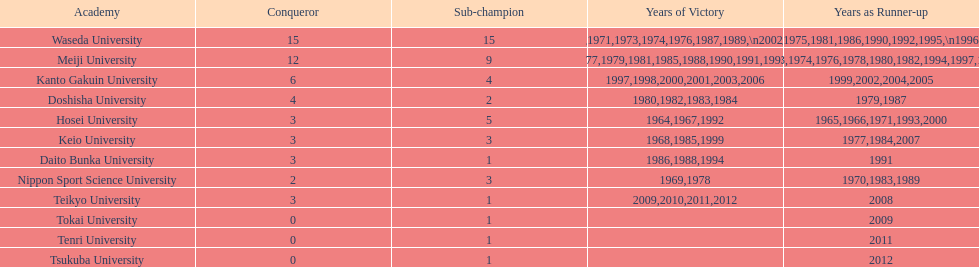At which university were the most years claimed as victories? Waseda University. 